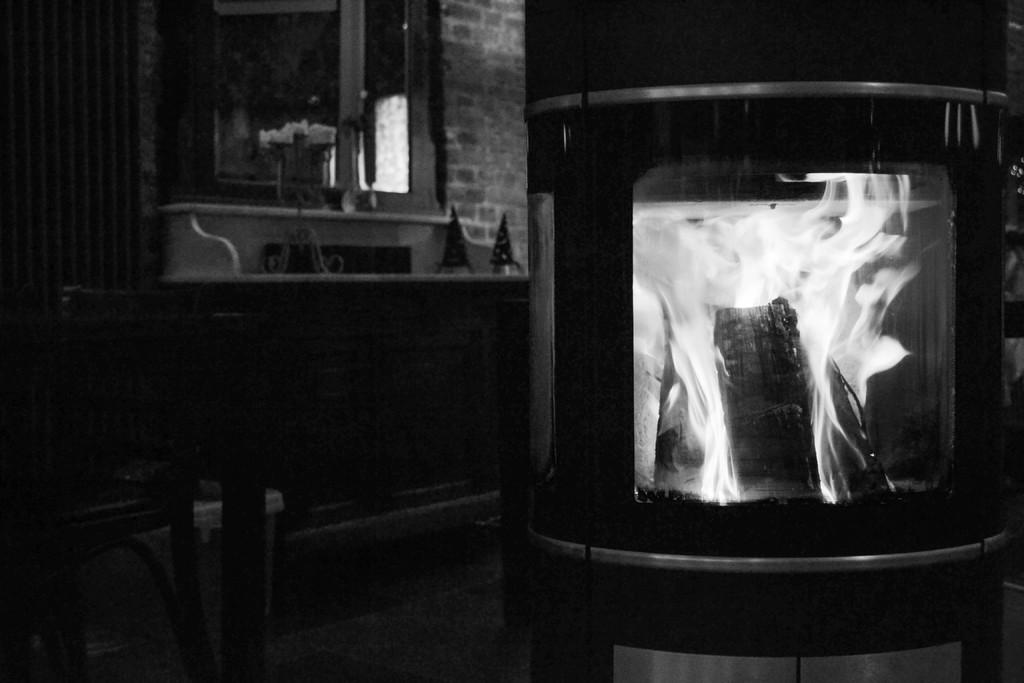What type of stove is visible in the image? There is a wood burning stove in the image. What type of furniture is present in the image? There is a chair in the image. What is behind the chair in the image? There is a wall behind the chair. What type of object is made of glass in the image? There is a glass object in the image. What type of furniture is present in the image, besides the chair? There is a table in the image. What is on the table in the image? There are objects on the table in the image. What type of watch is visible on the wall in the image? There is no watch present in the image; only a wood burning stove, chair, wall, glass object, table, and objects on the table are visible. 